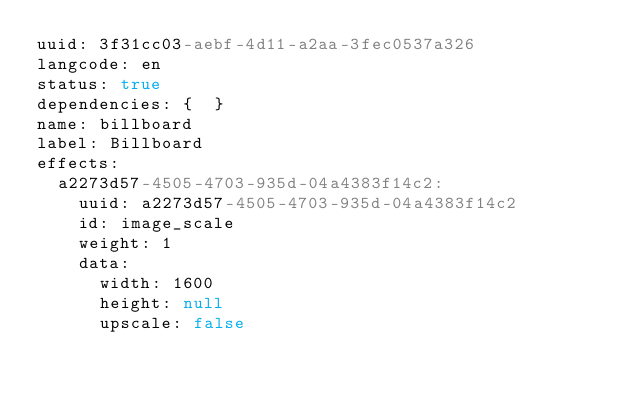Convert code to text. <code><loc_0><loc_0><loc_500><loc_500><_YAML_>uuid: 3f31cc03-aebf-4d11-a2aa-3fec0537a326
langcode: en
status: true
dependencies: {  }
name: billboard
label: Billboard
effects:
  a2273d57-4505-4703-935d-04a4383f14c2:
    uuid: a2273d57-4505-4703-935d-04a4383f14c2
    id: image_scale
    weight: 1
    data:
      width: 1600
      height: null
      upscale: false
</code> 